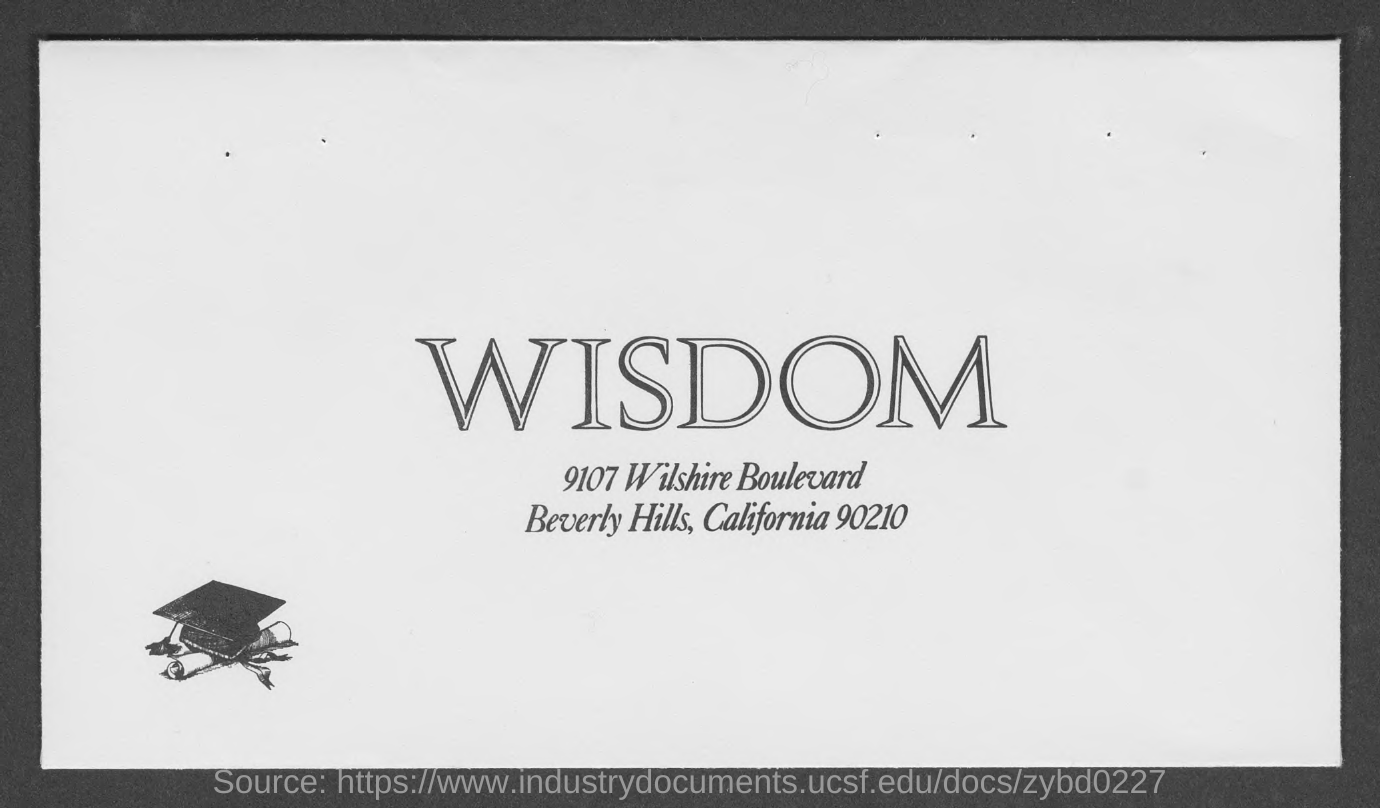What is the word written in the large font ?
Offer a terse response. WISDOM. Which country is mentioned in the document?
Offer a terse response. California. What is the zipcode ?
Ensure brevity in your answer.  90210. Which hills WISDOM is in ?
Provide a succinct answer. BEVERLY HILLS. 